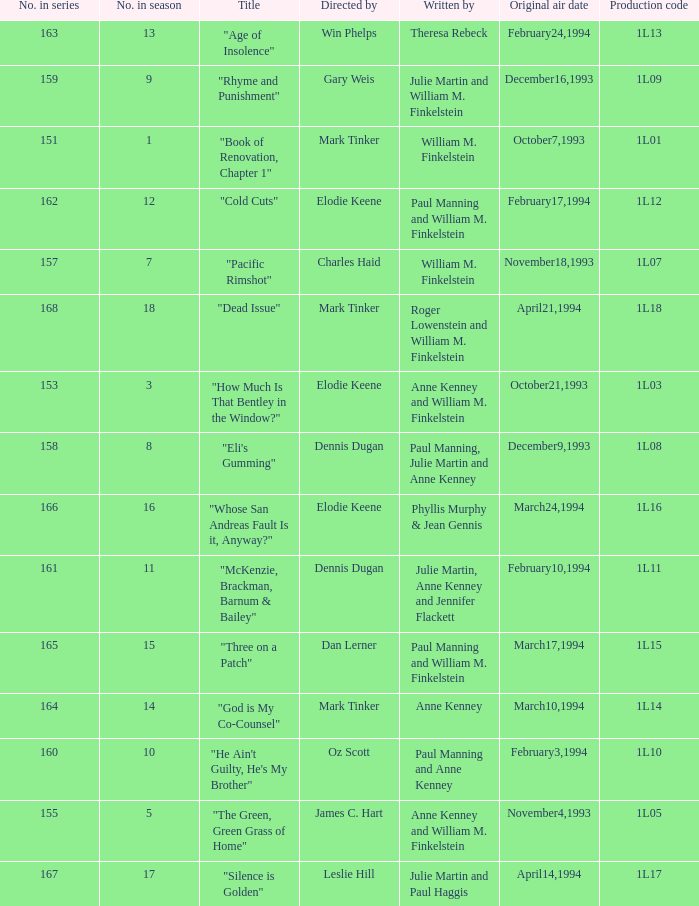Name the most number in season for leslie hill 17.0. 